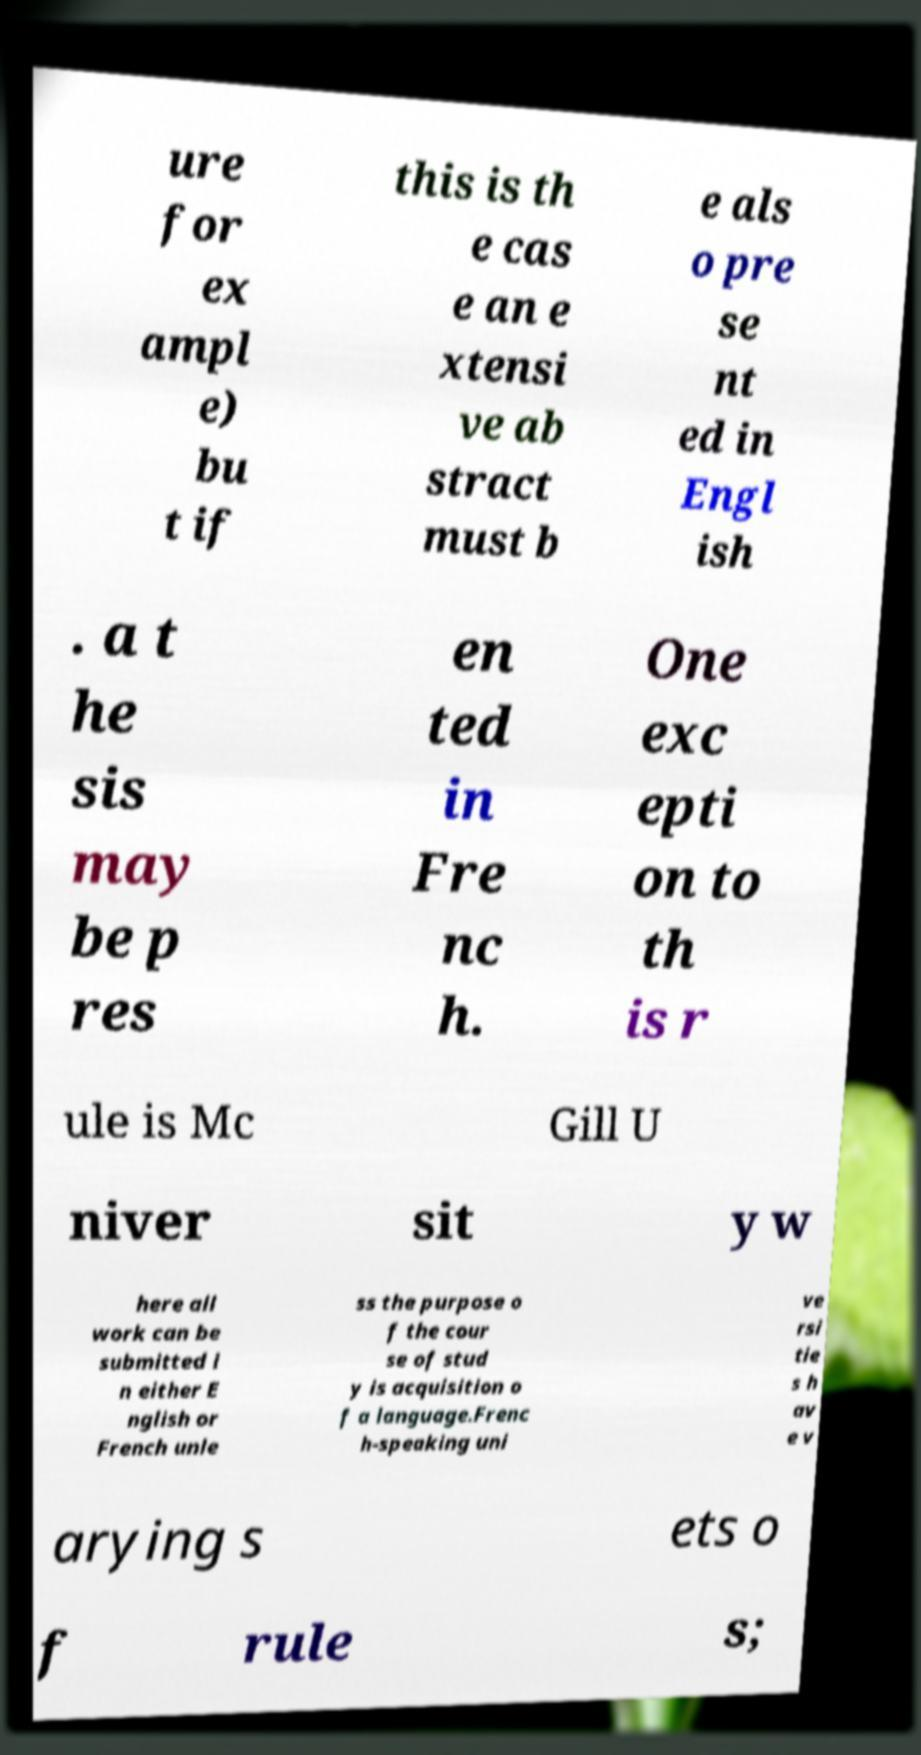Please identify and transcribe the text found in this image. ure for ex ampl e) bu t if this is th e cas e an e xtensi ve ab stract must b e als o pre se nt ed in Engl ish . a t he sis may be p res en ted in Fre nc h. One exc epti on to th is r ule is Mc Gill U niver sit y w here all work can be submitted i n either E nglish or French unle ss the purpose o f the cour se of stud y is acquisition o f a language.Frenc h-speaking uni ve rsi tie s h av e v arying s ets o f rule s; 